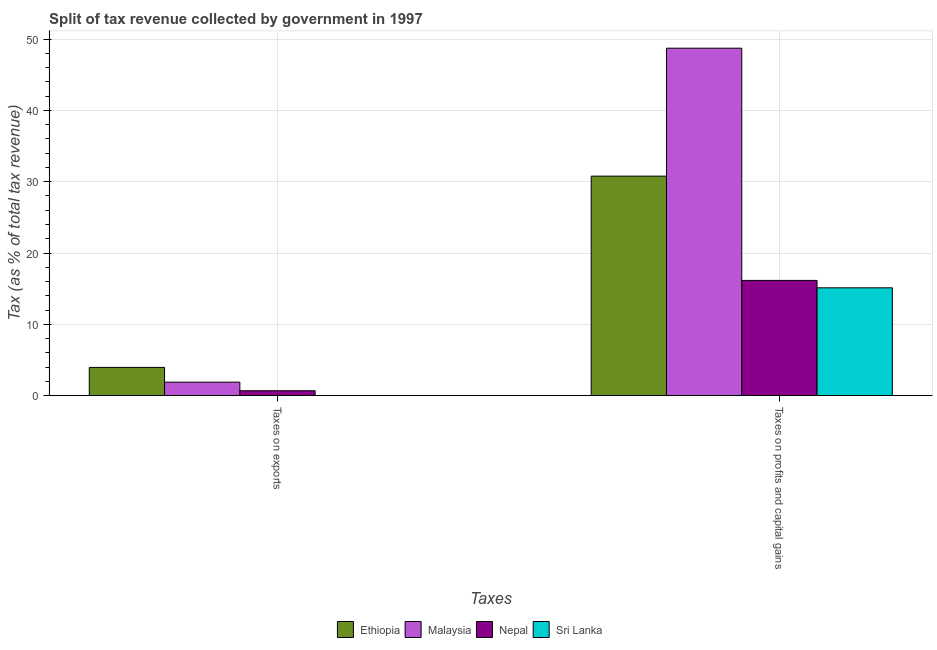How many groups of bars are there?
Give a very brief answer. 2. Are the number of bars per tick equal to the number of legend labels?
Your answer should be compact. Yes. Are the number of bars on each tick of the X-axis equal?
Make the answer very short. Yes. How many bars are there on the 2nd tick from the left?
Your answer should be compact. 4. How many bars are there on the 1st tick from the right?
Your response must be concise. 4. What is the label of the 1st group of bars from the left?
Offer a terse response. Taxes on exports. What is the percentage of revenue obtained from taxes on exports in Sri Lanka?
Offer a very short reply. 0. Across all countries, what is the maximum percentage of revenue obtained from taxes on exports?
Your answer should be compact. 3.96. Across all countries, what is the minimum percentage of revenue obtained from taxes on exports?
Make the answer very short. 0. In which country was the percentage of revenue obtained from taxes on profits and capital gains maximum?
Make the answer very short. Malaysia. In which country was the percentage of revenue obtained from taxes on exports minimum?
Provide a succinct answer. Sri Lanka. What is the total percentage of revenue obtained from taxes on profits and capital gains in the graph?
Your answer should be very brief. 110.78. What is the difference between the percentage of revenue obtained from taxes on profits and capital gains in Nepal and that in Sri Lanka?
Keep it short and to the point. 1.04. What is the difference between the percentage of revenue obtained from taxes on profits and capital gains in Nepal and the percentage of revenue obtained from taxes on exports in Sri Lanka?
Provide a short and direct response. 16.16. What is the average percentage of revenue obtained from taxes on profits and capital gains per country?
Offer a very short reply. 27.7. What is the difference between the percentage of revenue obtained from taxes on profits and capital gains and percentage of revenue obtained from taxes on exports in Nepal?
Provide a succinct answer. 15.47. What is the ratio of the percentage of revenue obtained from taxes on profits and capital gains in Sri Lanka to that in Ethiopia?
Provide a short and direct response. 0.49. In how many countries, is the percentage of revenue obtained from taxes on exports greater than the average percentage of revenue obtained from taxes on exports taken over all countries?
Ensure brevity in your answer.  2. What does the 2nd bar from the left in Taxes on exports represents?
Provide a succinct answer. Malaysia. What does the 1st bar from the right in Taxes on exports represents?
Your answer should be compact. Sri Lanka. How many bars are there?
Ensure brevity in your answer.  8. Are all the bars in the graph horizontal?
Keep it short and to the point. No. Are the values on the major ticks of Y-axis written in scientific E-notation?
Give a very brief answer. No. Where does the legend appear in the graph?
Ensure brevity in your answer.  Bottom center. How many legend labels are there?
Make the answer very short. 4. What is the title of the graph?
Provide a short and direct response. Split of tax revenue collected by government in 1997. What is the label or title of the X-axis?
Provide a succinct answer. Taxes. What is the label or title of the Y-axis?
Give a very brief answer. Tax (as % of total tax revenue). What is the Tax (as % of total tax revenue) in Ethiopia in Taxes on exports?
Offer a terse response. 3.96. What is the Tax (as % of total tax revenue) of Malaysia in Taxes on exports?
Your answer should be compact. 1.89. What is the Tax (as % of total tax revenue) of Nepal in Taxes on exports?
Provide a succinct answer. 0.69. What is the Tax (as % of total tax revenue) of Sri Lanka in Taxes on exports?
Your answer should be very brief. 0. What is the Tax (as % of total tax revenue) of Ethiopia in Taxes on profits and capital gains?
Keep it short and to the point. 30.78. What is the Tax (as % of total tax revenue) of Malaysia in Taxes on profits and capital gains?
Your answer should be compact. 48.72. What is the Tax (as % of total tax revenue) in Nepal in Taxes on profits and capital gains?
Give a very brief answer. 16.16. What is the Tax (as % of total tax revenue) in Sri Lanka in Taxes on profits and capital gains?
Keep it short and to the point. 15.12. Across all Taxes, what is the maximum Tax (as % of total tax revenue) of Ethiopia?
Keep it short and to the point. 30.78. Across all Taxes, what is the maximum Tax (as % of total tax revenue) of Malaysia?
Your answer should be very brief. 48.72. Across all Taxes, what is the maximum Tax (as % of total tax revenue) in Nepal?
Your response must be concise. 16.16. Across all Taxes, what is the maximum Tax (as % of total tax revenue) in Sri Lanka?
Keep it short and to the point. 15.12. Across all Taxes, what is the minimum Tax (as % of total tax revenue) in Ethiopia?
Your answer should be very brief. 3.96. Across all Taxes, what is the minimum Tax (as % of total tax revenue) in Malaysia?
Ensure brevity in your answer.  1.89. Across all Taxes, what is the minimum Tax (as % of total tax revenue) in Nepal?
Offer a terse response. 0.69. Across all Taxes, what is the minimum Tax (as % of total tax revenue) of Sri Lanka?
Ensure brevity in your answer.  0. What is the total Tax (as % of total tax revenue) of Ethiopia in the graph?
Your answer should be compact. 34.74. What is the total Tax (as % of total tax revenue) in Malaysia in the graph?
Make the answer very short. 50.61. What is the total Tax (as % of total tax revenue) of Nepal in the graph?
Your response must be concise. 16.84. What is the total Tax (as % of total tax revenue) of Sri Lanka in the graph?
Your answer should be compact. 15.12. What is the difference between the Tax (as % of total tax revenue) in Ethiopia in Taxes on exports and that in Taxes on profits and capital gains?
Offer a terse response. -26.82. What is the difference between the Tax (as % of total tax revenue) in Malaysia in Taxes on exports and that in Taxes on profits and capital gains?
Make the answer very short. -46.83. What is the difference between the Tax (as % of total tax revenue) of Nepal in Taxes on exports and that in Taxes on profits and capital gains?
Your response must be concise. -15.47. What is the difference between the Tax (as % of total tax revenue) of Sri Lanka in Taxes on exports and that in Taxes on profits and capital gains?
Provide a short and direct response. -15.12. What is the difference between the Tax (as % of total tax revenue) of Ethiopia in Taxes on exports and the Tax (as % of total tax revenue) of Malaysia in Taxes on profits and capital gains?
Ensure brevity in your answer.  -44.76. What is the difference between the Tax (as % of total tax revenue) of Ethiopia in Taxes on exports and the Tax (as % of total tax revenue) of Nepal in Taxes on profits and capital gains?
Your answer should be very brief. -12.2. What is the difference between the Tax (as % of total tax revenue) in Ethiopia in Taxes on exports and the Tax (as % of total tax revenue) in Sri Lanka in Taxes on profits and capital gains?
Your response must be concise. -11.16. What is the difference between the Tax (as % of total tax revenue) of Malaysia in Taxes on exports and the Tax (as % of total tax revenue) of Nepal in Taxes on profits and capital gains?
Keep it short and to the point. -14.27. What is the difference between the Tax (as % of total tax revenue) of Malaysia in Taxes on exports and the Tax (as % of total tax revenue) of Sri Lanka in Taxes on profits and capital gains?
Your answer should be very brief. -13.23. What is the difference between the Tax (as % of total tax revenue) in Nepal in Taxes on exports and the Tax (as % of total tax revenue) in Sri Lanka in Taxes on profits and capital gains?
Offer a terse response. -14.43. What is the average Tax (as % of total tax revenue) of Ethiopia per Taxes?
Provide a succinct answer. 17.37. What is the average Tax (as % of total tax revenue) of Malaysia per Taxes?
Make the answer very short. 25.31. What is the average Tax (as % of total tax revenue) of Nepal per Taxes?
Provide a short and direct response. 8.42. What is the average Tax (as % of total tax revenue) in Sri Lanka per Taxes?
Make the answer very short. 7.56. What is the difference between the Tax (as % of total tax revenue) in Ethiopia and Tax (as % of total tax revenue) in Malaysia in Taxes on exports?
Provide a short and direct response. 2.07. What is the difference between the Tax (as % of total tax revenue) of Ethiopia and Tax (as % of total tax revenue) of Nepal in Taxes on exports?
Your response must be concise. 3.27. What is the difference between the Tax (as % of total tax revenue) of Ethiopia and Tax (as % of total tax revenue) of Sri Lanka in Taxes on exports?
Your answer should be compact. 3.96. What is the difference between the Tax (as % of total tax revenue) of Malaysia and Tax (as % of total tax revenue) of Nepal in Taxes on exports?
Provide a succinct answer. 1.21. What is the difference between the Tax (as % of total tax revenue) in Malaysia and Tax (as % of total tax revenue) in Sri Lanka in Taxes on exports?
Provide a short and direct response. 1.89. What is the difference between the Tax (as % of total tax revenue) in Nepal and Tax (as % of total tax revenue) in Sri Lanka in Taxes on exports?
Your answer should be compact. 0.68. What is the difference between the Tax (as % of total tax revenue) of Ethiopia and Tax (as % of total tax revenue) of Malaysia in Taxes on profits and capital gains?
Ensure brevity in your answer.  -17.94. What is the difference between the Tax (as % of total tax revenue) in Ethiopia and Tax (as % of total tax revenue) in Nepal in Taxes on profits and capital gains?
Provide a succinct answer. 14.62. What is the difference between the Tax (as % of total tax revenue) in Ethiopia and Tax (as % of total tax revenue) in Sri Lanka in Taxes on profits and capital gains?
Ensure brevity in your answer.  15.66. What is the difference between the Tax (as % of total tax revenue) of Malaysia and Tax (as % of total tax revenue) of Nepal in Taxes on profits and capital gains?
Ensure brevity in your answer.  32.56. What is the difference between the Tax (as % of total tax revenue) of Malaysia and Tax (as % of total tax revenue) of Sri Lanka in Taxes on profits and capital gains?
Your answer should be compact. 33.6. What is the difference between the Tax (as % of total tax revenue) in Nepal and Tax (as % of total tax revenue) in Sri Lanka in Taxes on profits and capital gains?
Your answer should be very brief. 1.04. What is the ratio of the Tax (as % of total tax revenue) in Ethiopia in Taxes on exports to that in Taxes on profits and capital gains?
Make the answer very short. 0.13. What is the ratio of the Tax (as % of total tax revenue) of Malaysia in Taxes on exports to that in Taxes on profits and capital gains?
Make the answer very short. 0.04. What is the ratio of the Tax (as % of total tax revenue) of Nepal in Taxes on exports to that in Taxes on profits and capital gains?
Offer a terse response. 0.04. What is the ratio of the Tax (as % of total tax revenue) in Sri Lanka in Taxes on exports to that in Taxes on profits and capital gains?
Keep it short and to the point. 0. What is the difference between the highest and the second highest Tax (as % of total tax revenue) of Ethiopia?
Provide a short and direct response. 26.82. What is the difference between the highest and the second highest Tax (as % of total tax revenue) in Malaysia?
Your answer should be compact. 46.83. What is the difference between the highest and the second highest Tax (as % of total tax revenue) of Nepal?
Ensure brevity in your answer.  15.47. What is the difference between the highest and the second highest Tax (as % of total tax revenue) of Sri Lanka?
Provide a succinct answer. 15.12. What is the difference between the highest and the lowest Tax (as % of total tax revenue) of Ethiopia?
Make the answer very short. 26.82. What is the difference between the highest and the lowest Tax (as % of total tax revenue) in Malaysia?
Offer a very short reply. 46.83. What is the difference between the highest and the lowest Tax (as % of total tax revenue) in Nepal?
Provide a succinct answer. 15.47. What is the difference between the highest and the lowest Tax (as % of total tax revenue) of Sri Lanka?
Ensure brevity in your answer.  15.12. 